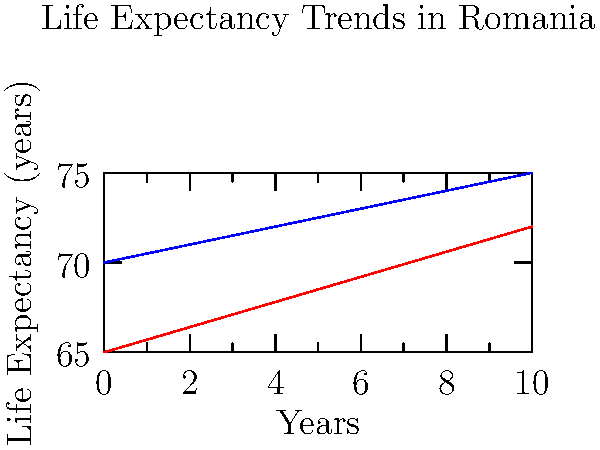As a concerned Romanian public health advocate, analyze the graph showing life expectancy trends in urban and rural areas of Romania. What conclusion can you draw about the life expectancy gap between urban and rural areas over time? To analyze the life expectancy gap between urban and rural areas over time, we need to follow these steps:

1. Observe the starting points:
   - Urban (blue line): starts at about 70 years
   - Rural (red line): starts at about 65 years
   Initial gap: approximately 5 years

2. Examine the slopes of the lines:
   - Urban line has a gentler slope
   - Rural line has a steeper slope

3. Compare the rates of increase:
   - Urban life expectancy is increasing more slowly
   - Rural life expectancy is increasing more rapidly

4. Project the lines forward:
   - The lines are converging as time progresses

5. Interpret the trend:
   - The life expectancy gap between urban and rural areas is narrowing over time

This trend suggests that rural areas are catching up to urban areas in terms of life expectancy, possibly due to improvements in healthcare access, living conditions, or public health initiatives in rural regions of Romania.
Answer: The life expectancy gap between urban and rural areas is narrowing over time. 